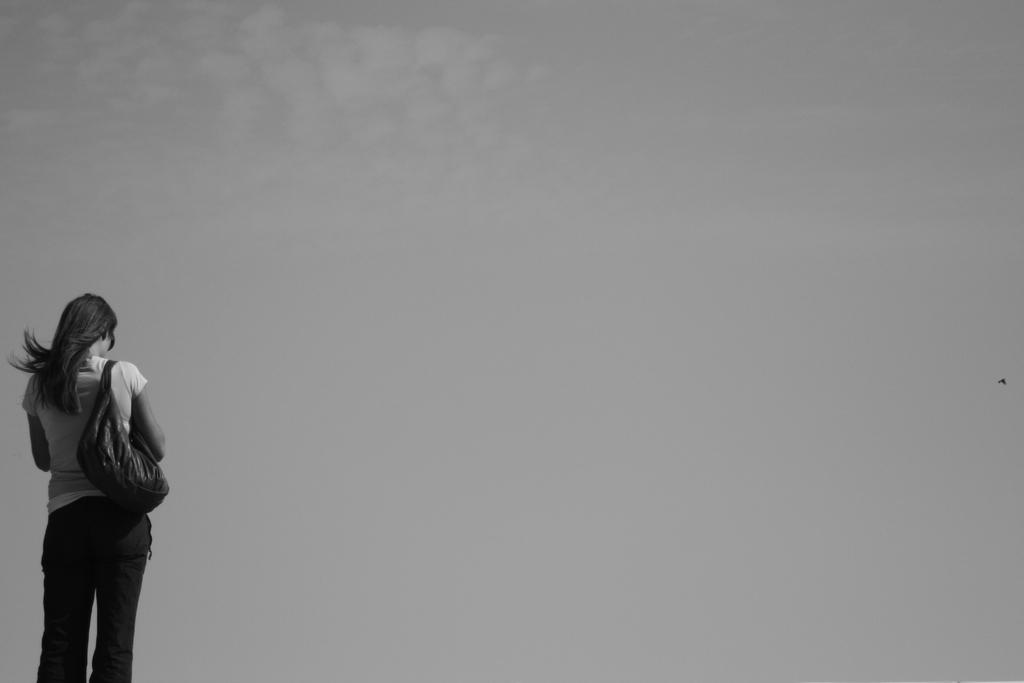What is the color scheme of the image? The image is black and white. What can be seen on the left side of the image? There is a person standing on the left side of the image. What is the person wearing? The person is wearing a bag. What is visible in the background of the image? The sky is visible in the background of the image. What type of weather can be inferred from the background? Clouds are present in the background of the image, suggesting that it might be a cloudy day. How many worms can be seen crawling on the person's bag in the image? There are no worms present in the image; the person is wearing a bag, but no worms are visible. 